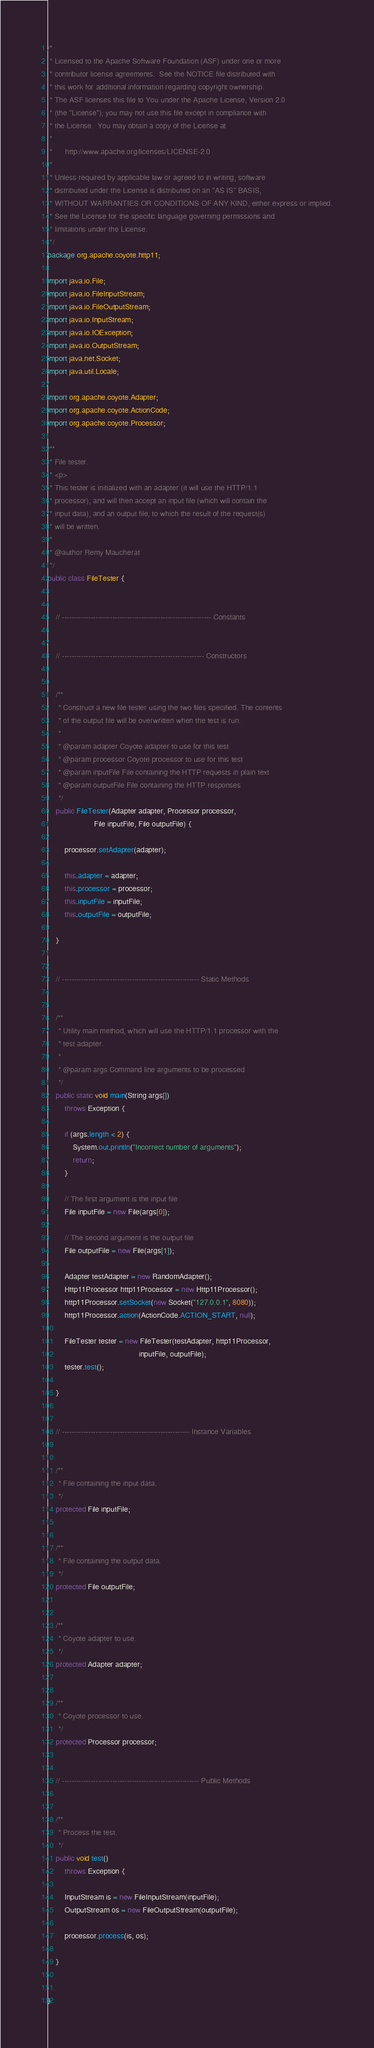<code> <loc_0><loc_0><loc_500><loc_500><_Java_>/*
 * Licensed to the Apache Software Foundation (ASF) under one or more
 * contributor license agreements.  See the NOTICE file distributed with
 * this work for additional information regarding copyright ownership.
 * The ASF licenses this file to You under the Apache License, Version 2.0
 * (the "License"); you may not use this file except in compliance with
 * the License.  You may obtain a copy of the License at
 * 
 *      http://www.apache.org/licenses/LICENSE-2.0
 * 
 * Unless required by applicable law or agreed to in writing, software
 * distributed under the License is distributed on an "AS IS" BASIS,
 * WITHOUT WARRANTIES OR CONDITIONS OF ANY KIND, either express or implied.
 * See the License for the specific language governing permissions and
 * limitations under the License.
 */ 
package org.apache.coyote.http11;

import java.io.File;
import java.io.FileInputStream;
import java.io.FileOutputStream;
import java.io.InputStream;
import java.io.IOException;
import java.io.OutputStream;
import java.net.Socket;
import java.util.Locale;

import org.apache.coyote.Adapter;
import org.apache.coyote.ActionCode;
import org.apache.coyote.Processor;

/**
 * File tester.
 * <p>
 * This tester is initialized with an adapter (it will use the HTTP/1.1 
 * processor), and will then accept an input file (which will contain the 
 * input data), and an output file, to which the result of the request(s)
 * will be written.
 *
 * @author Remy Maucherat
 */
public class FileTester {


    // -------------------------------------------------------------- Constants


    // ----------------------------------------------------------- Constructors


    /**
     * Construct a new file tester using the two files specified. The contents
     * of the output file will be overwritten when the test is run.
     * 
     * @param adapter Coyote adapter to use for this test
     * @param processor Coyote processor to use for this test
     * @param inputFile File containing the HTTP requests in plain text
     * @param outputFile File containing the HTTP responses
     */
    public FileTester(Adapter adapter, Processor processor,
                      File inputFile, File outputFile) {

        processor.setAdapter(adapter);

        this.adapter = adapter;
        this.processor = processor;
        this.inputFile = inputFile;
        this.outputFile = outputFile;

    }


    // --------------------------------------------------------- Static Methods


    /**
     * Utility main method, which will use the HTTP/1.1 processor with the 
     * test adapter.
     *
     * @param args Command line arguments to be processed
     */
    public static void main(String args[])
        throws Exception {

        if (args.length < 2) {
            System.out.println("Incorrect number of arguments");
            return;
        }

        // The first argument is the input file
        File inputFile = new File(args[0]);

        // The second argument is the output file
        File outputFile = new File(args[1]);

        Adapter testAdapter = new RandomAdapter();
        Http11Processor http11Processor = new Http11Processor();
        http11Processor.setSocket(new Socket("127.0.0.1", 8080));
        http11Processor.action(ActionCode.ACTION_START, null);

        FileTester tester = new FileTester(testAdapter, http11Processor,
                                           inputFile, outputFile);
        tester.test();

    }


    // ----------------------------------------------------- Instance Variables


    /**
     * File containing the input data.
     */
    protected File inputFile;


    /**
     * File containing the output data.
     */
    protected File outputFile;


    /**
     * Coyote adapter to use.
     */
    protected Adapter adapter;


    /**
     * Coyote processor to use.
     */
    protected Processor processor;


    // --------------------------------------------------------- Public Methods


    /**
     * Process the test.
     */
    public void test()
        throws Exception {

        InputStream is = new FileInputStream(inputFile);
        OutputStream os = new FileOutputStream(outputFile);

        processor.process(is, os);

    }


}
</code> 